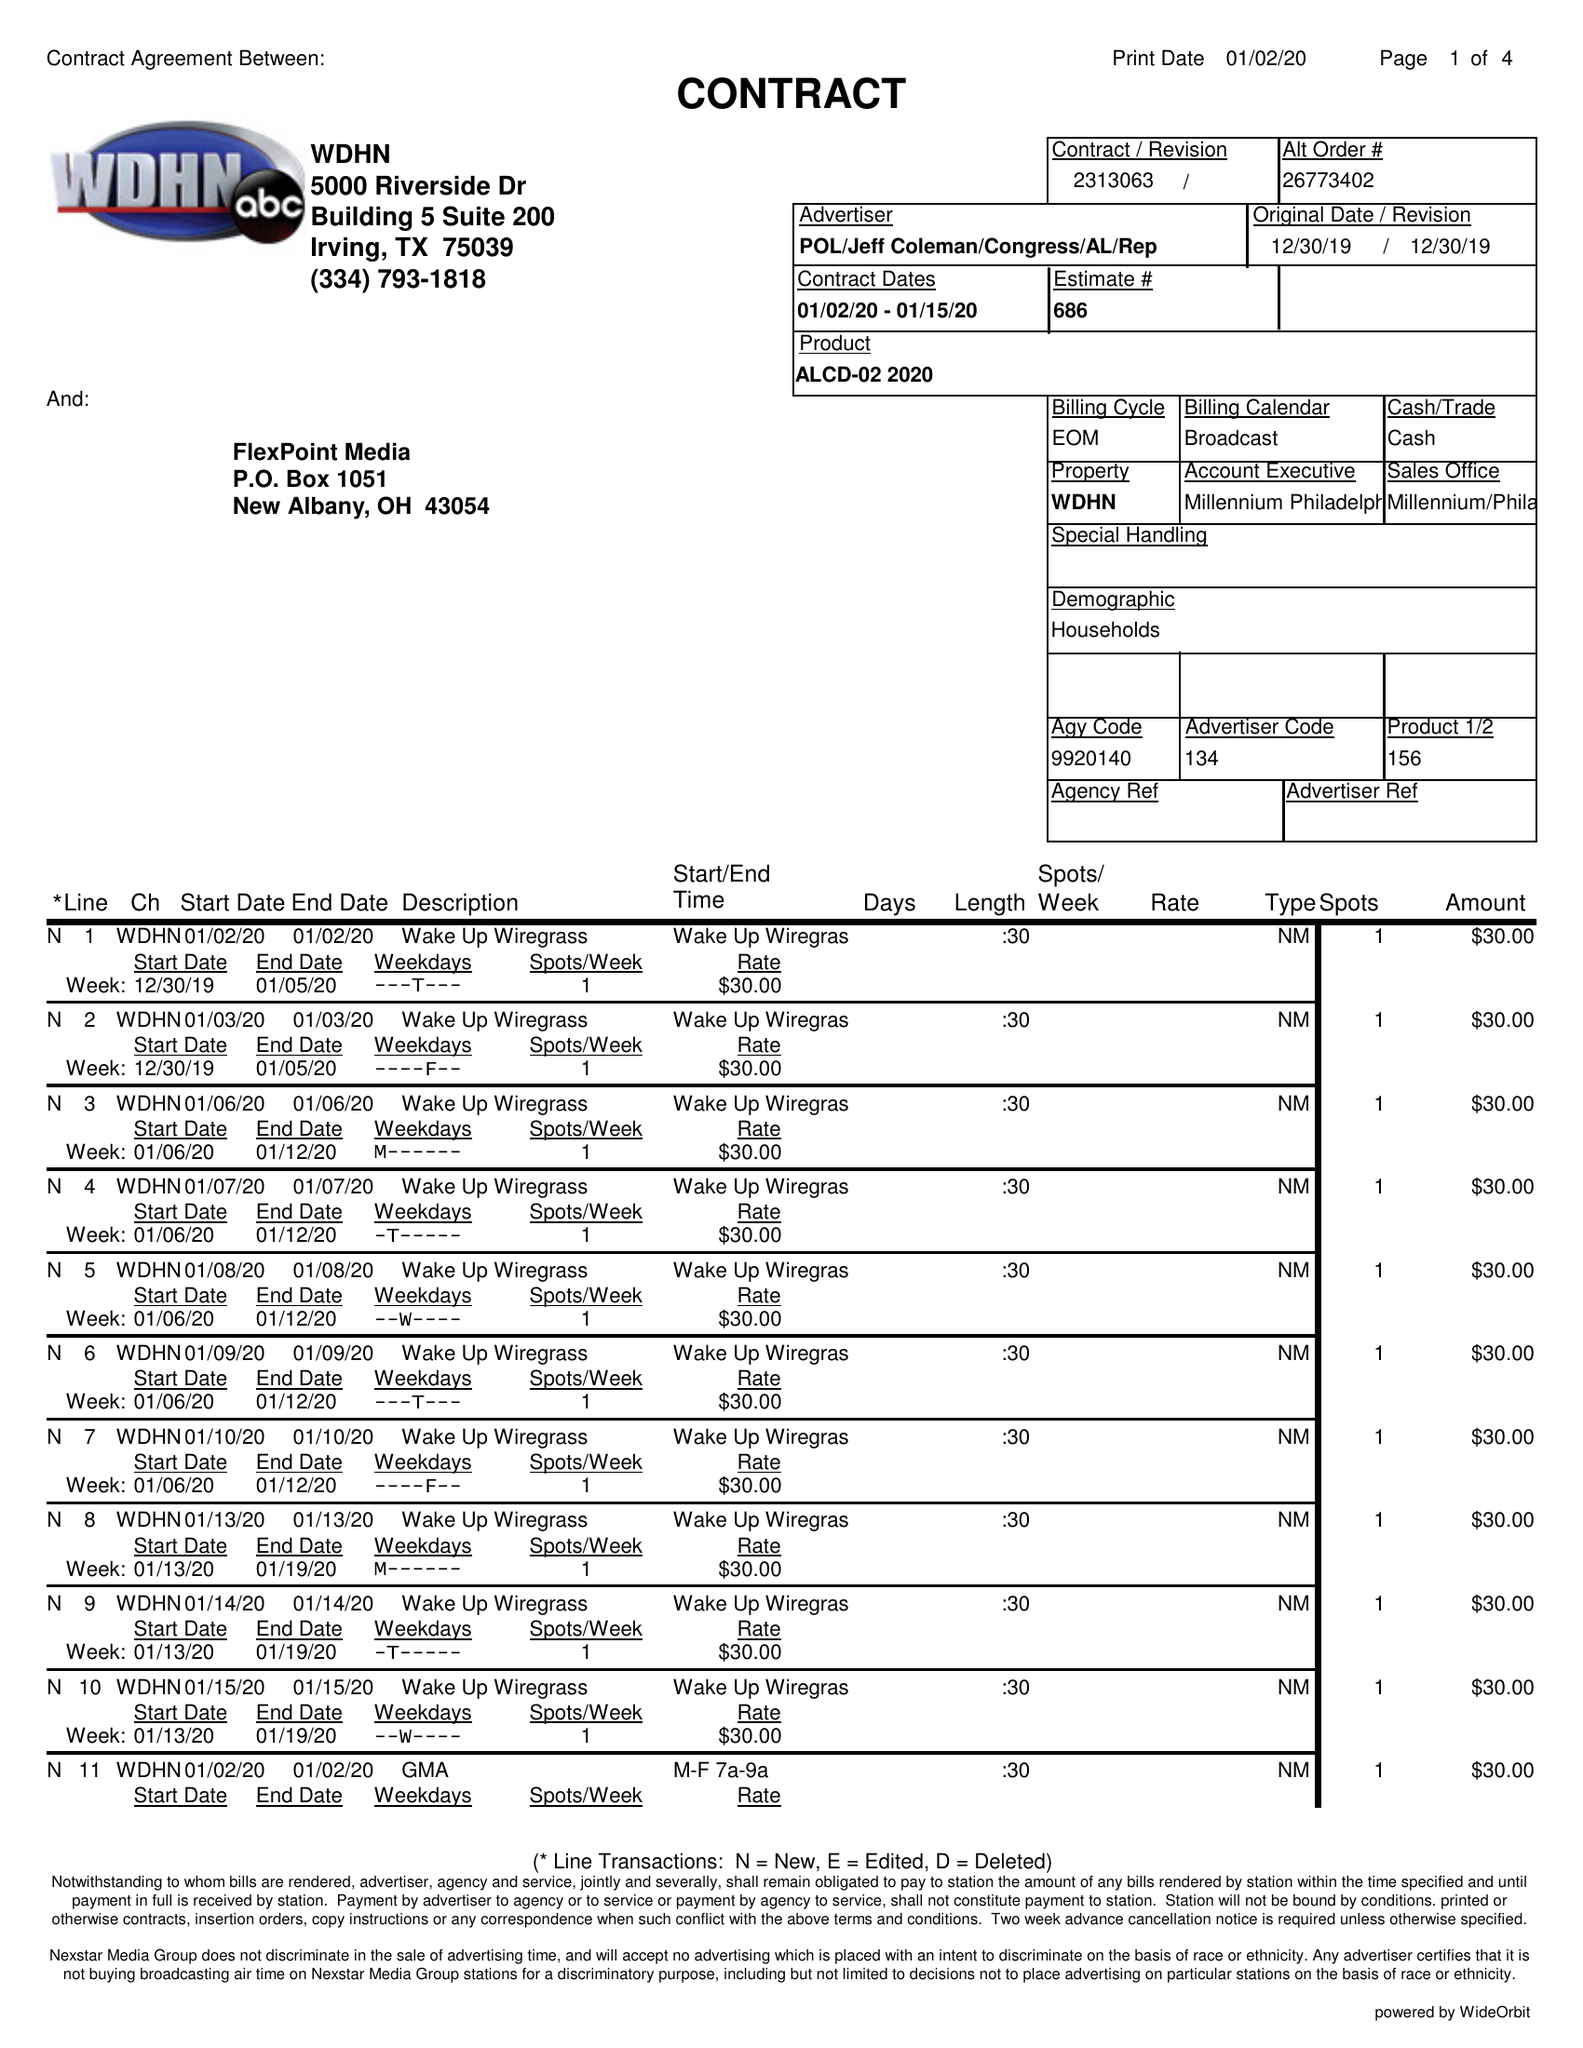What is the value for the gross_amount?
Answer the question using a single word or phrase. 3525.00 